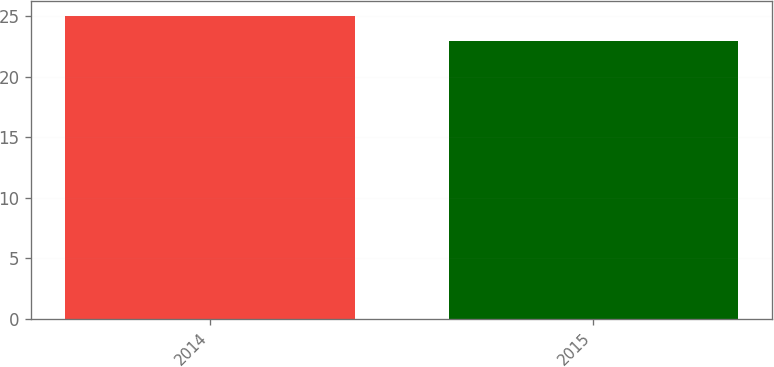Convert chart. <chart><loc_0><loc_0><loc_500><loc_500><bar_chart><fcel>2014<fcel>2015<nl><fcel>25<fcel>23<nl></chart> 